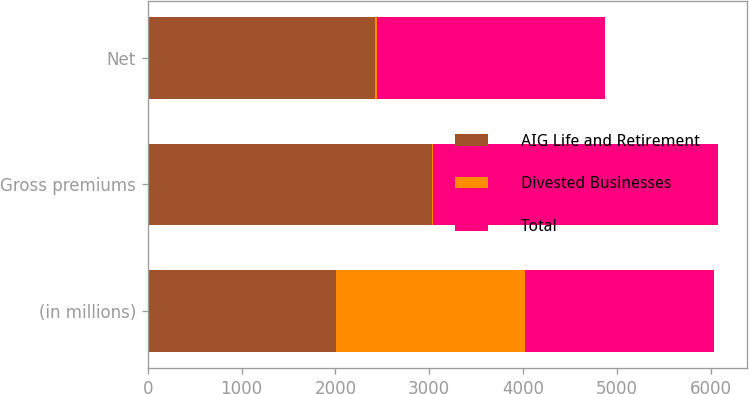Convert chart to OTSL. <chart><loc_0><loc_0><loc_500><loc_500><stacked_bar_chart><ecel><fcel>(in millions)<fcel>Gross premiums<fcel>Net<nl><fcel>AIG Life and Retirement<fcel>2012<fcel>3030<fcel>2428<nl><fcel>Divested Businesses<fcel>2012<fcel>11<fcel>11<nl><fcel>Total<fcel>2012<fcel>3041<fcel>2439<nl></chart> 